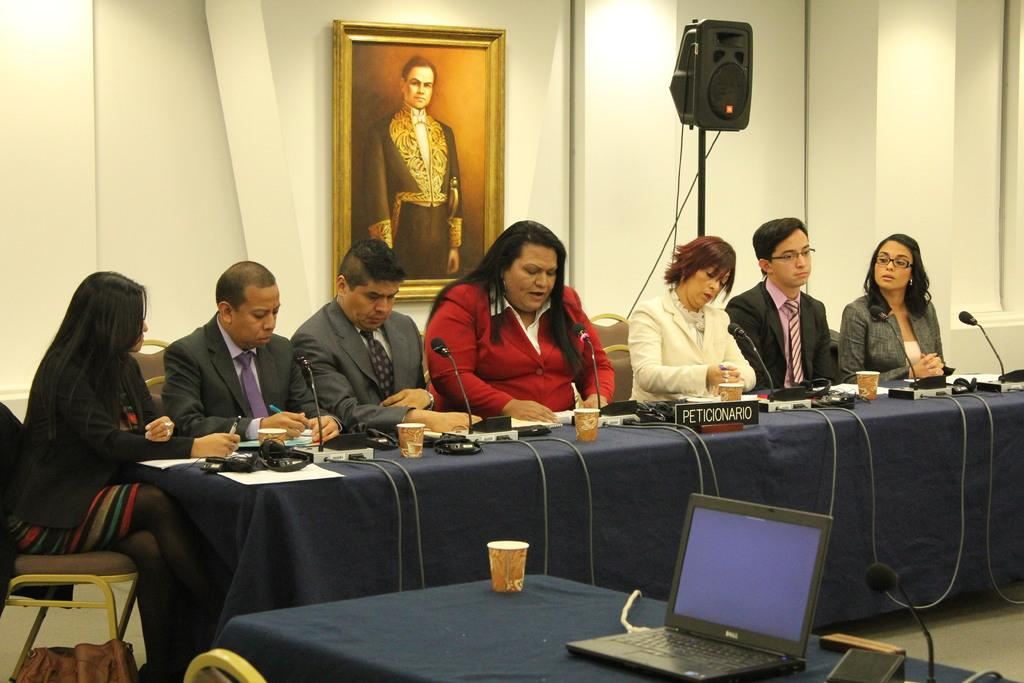<image>
Describe the image concisely. People sitting behind a desk with a sign that says "PETICIONARIO". 